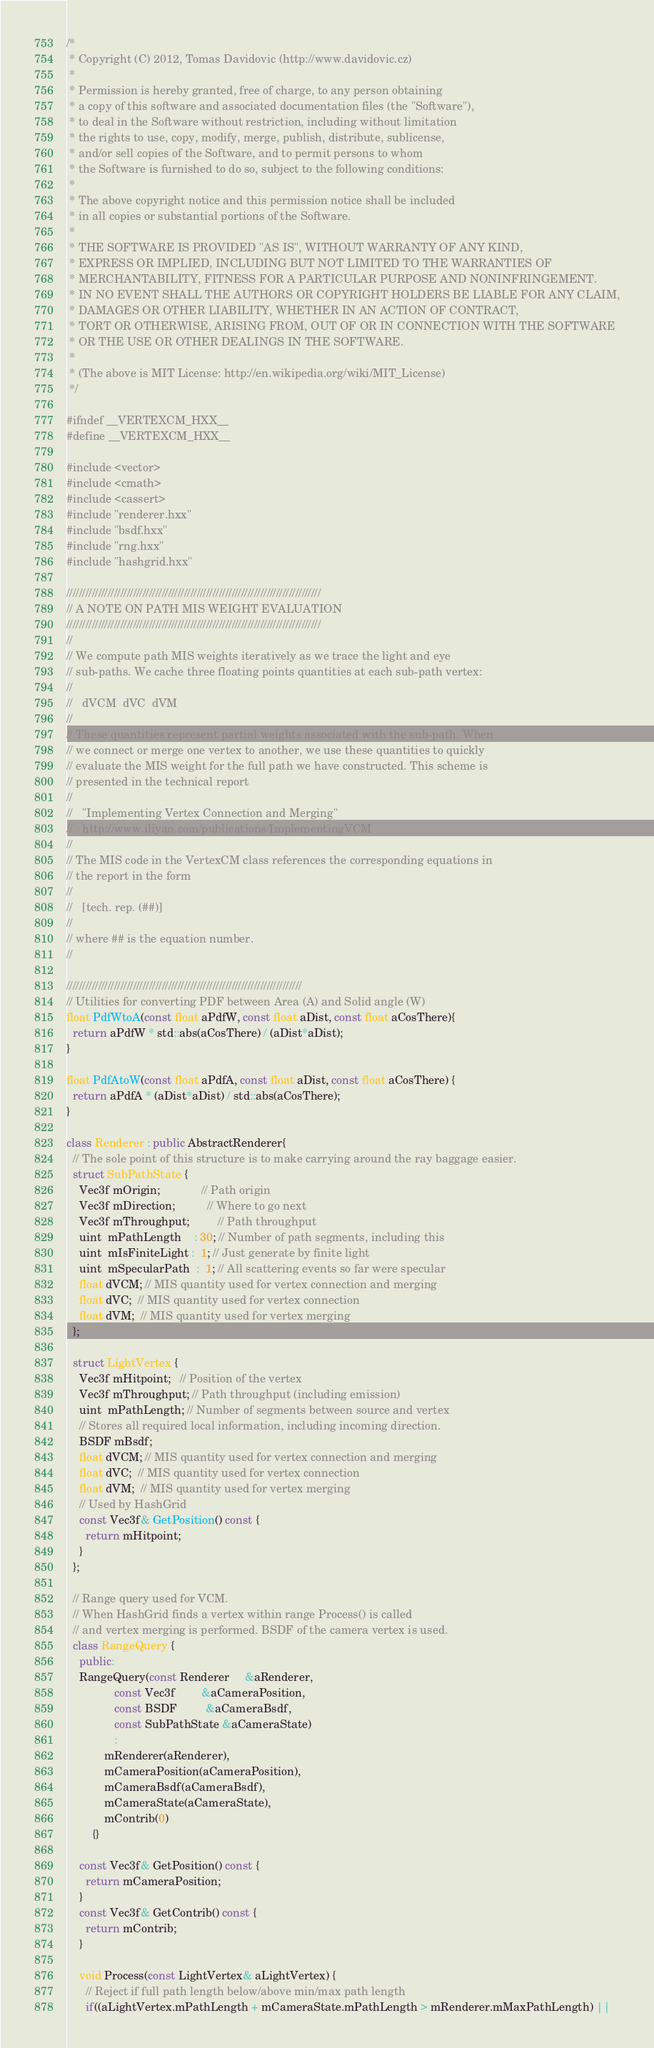Convert code to text. <code><loc_0><loc_0><loc_500><loc_500><_C++_>/*
 * Copyright (C) 2012, Tomas Davidovic (http://www.davidovic.cz)
 *
 * Permission is hereby granted, free of charge, to any person obtaining
 * a copy of this software and associated documentation files (the "Software"),
 * to deal in the Software without restriction, including without limitation
 * the rights to use, copy, modify, merge, publish, distribute, sublicense,
 * and/or sell copies of the Software, and to permit persons to whom
 * the Software is furnished to do so, subject to the following conditions:
 *
 * The above copyright notice and this permission notice shall be included
 * in all copies or substantial portions of the Software.
 *
 * THE SOFTWARE IS PROVIDED "AS IS", WITHOUT WARRANTY OF ANY KIND,
 * EXPRESS OR IMPLIED, INCLUDING BUT NOT LIMITED TO THE WARRANTIES OF
 * MERCHANTABILITY, FITNESS FOR A PARTICULAR PURPOSE AND NONINFRINGEMENT.
 * IN NO EVENT SHALL THE AUTHORS OR COPYRIGHT HOLDERS BE LIABLE FOR ANY CLAIM,
 * DAMAGES OR OTHER LIABILITY, WHETHER IN AN ACTION OF CONTRACT,
 * TORT OR OTHERWISE, ARISING FROM, OUT OF OR IN CONNECTION WITH THE SOFTWARE
 * OR THE USE OR OTHER DEALINGS IN THE SOFTWARE.
 *
 * (The above is MIT License: http://en.wikipedia.org/wiki/MIT_License)
 */

#ifndef __VERTEXCM_HXX__
#define __VERTEXCM_HXX__

#include <vector>
#include <cmath>
#include <cassert>
#include "renderer.hxx"
#include "bsdf.hxx"
#include "rng.hxx"
#include "hashgrid.hxx"

////////////////////////////////////////////////////////////////////////////////
// A NOTE ON PATH MIS WEIGHT EVALUATION
////////////////////////////////////////////////////////////////////////////////
//
// We compute path MIS weights iteratively as we trace the light and eye
// sub-paths. We cache three floating points quantities at each sub-path vertex:
//
//   dVCM  dVC  dVM
//
// These quantities represent partial weights associated with the sub-path. When
// we connect or merge one vertex to another, we use these quantities to quickly
// evaluate the MIS weight for the full path we have constructed. This scheme is
// presented in the technical report
//
//   "Implementing Vertex Connection and Merging"
//   http://www.iliyan.com/publications/ImplementingVCM
//
// The MIS code in the VertexCM class references the corresponding equations in
// the report in the form
//
//   [tech. rep. (##)]
//
// where ## is the equation number.
//

//////////////////////////////////////////////////////////////////////////
// Utilities for converting PDF between Area (A) and Solid angle (W)
float PdfWtoA(const float aPdfW, const float aDist, const float aCosThere){
  return aPdfW * std::abs(aCosThere) / (aDist*aDist);
}

float PdfAtoW(const float aPdfA, const float aDist, const float aCosThere) {
  return aPdfA * (aDist*aDist) / std::abs(aCosThere);
}

class Renderer : public AbstractRenderer{
  // The sole point of this structure is to make carrying around the ray baggage easier.
  struct SubPathState {
    Vec3f mOrigin;             // Path origin
    Vec3f mDirection;          // Where to go next
    Vec3f mThroughput;         // Path throughput
    uint  mPathLength    : 30; // Number of path segments, including this
    uint  mIsFiniteLight :  1; // Just generate by finite light
    uint  mSpecularPath  :  1; // All scattering events so far were specular
    float dVCM; // MIS quantity used for vertex connection and merging
    float dVC;  // MIS quantity used for vertex connection
    float dVM;  // MIS quantity used for vertex merging
  };

  struct LightVertex {
    Vec3f mHitpoint;   // Position of the vertex
    Vec3f mThroughput; // Path throughput (including emission)
    uint  mPathLength; // Number of segments between source and vertex
    // Stores all required local information, including incoming direction.
    BSDF mBsdf;
    float dVCM; // MIS quantity used for vertex connection and merging
    float dVC;  // MIS quantity used for vertex connection
    float dVM;  // MIS quantity used for vertex merging
    // Used by HashGrid
    const Vec3f& GetPosition() const {
      return mHitpoint;
    }
  };

  // Range query used for VCM.
  // When HashGrid finds a vertex within range Process() is called
  // and vertex merging is performed. BSDF of the camera vertex is used.
  class RangeQuery {
    public:
    RangeQuery(const Renderer     &aRenderer,
               const Vec3f        &aCameraPosition,
               const BSDF         &aCameraBsdf,
               const SubPathState &aCameraState)
               :
            mRenderer(aRenderer),
            mCameraPosition(aCameraPosition),
            mCameraBsdf(aCameraBsdf),
            mCameraState(aCameraState),
            mContrib(0)
        {}

    const Vec3f& GetPosition() const {
      return mCameraPosition;
    }
    const Vec3f& GetContrib() const {
      return mContrib;
    }

    void Process(const LightVertex& aLightVertex) {
      // Reject if full path length below/above min/max path length
      if((aLightVertex.mPathLength + mCameraState.mPathLength > mRenderer.mMaxPathLength) ||</code> 